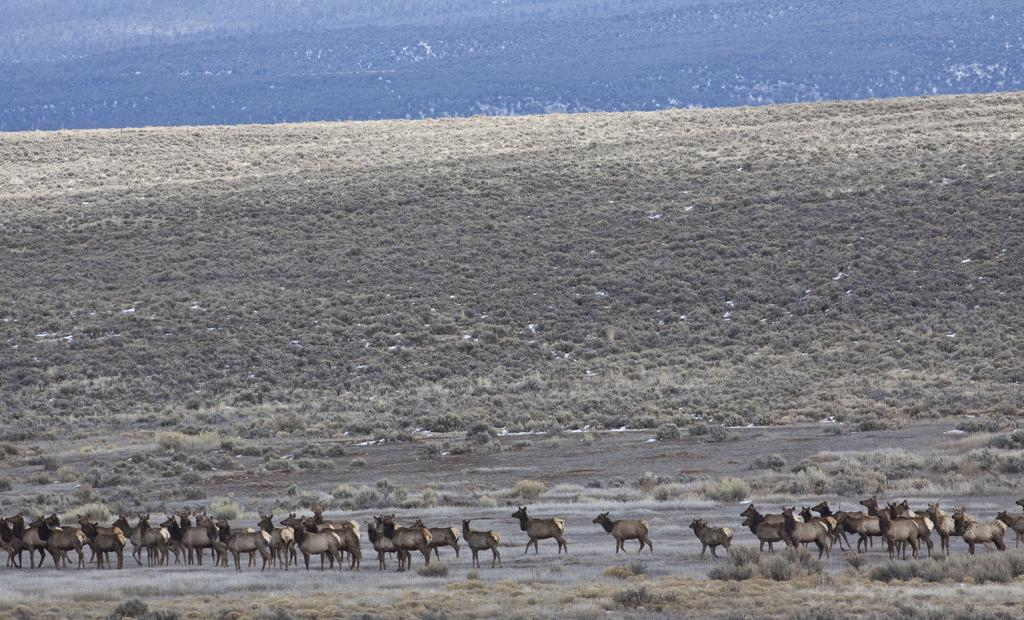What type of living organisms can be seen on the ground in the image? There are animals on the ground in the image. What type of vegetation is present in the image? Dried shrubs and dried grass are visible in the image. What geographical feature can be seen at the top of the image? There is a hill at the top of the image. What type of sheet is covering the hill in the image? There is no sheet present in the image; the hill is visible without any covering. How much sugar can be seen on the ground in the image? There is no sugar present in the image; the ground features animals, dried shrubs, and dried grass. 